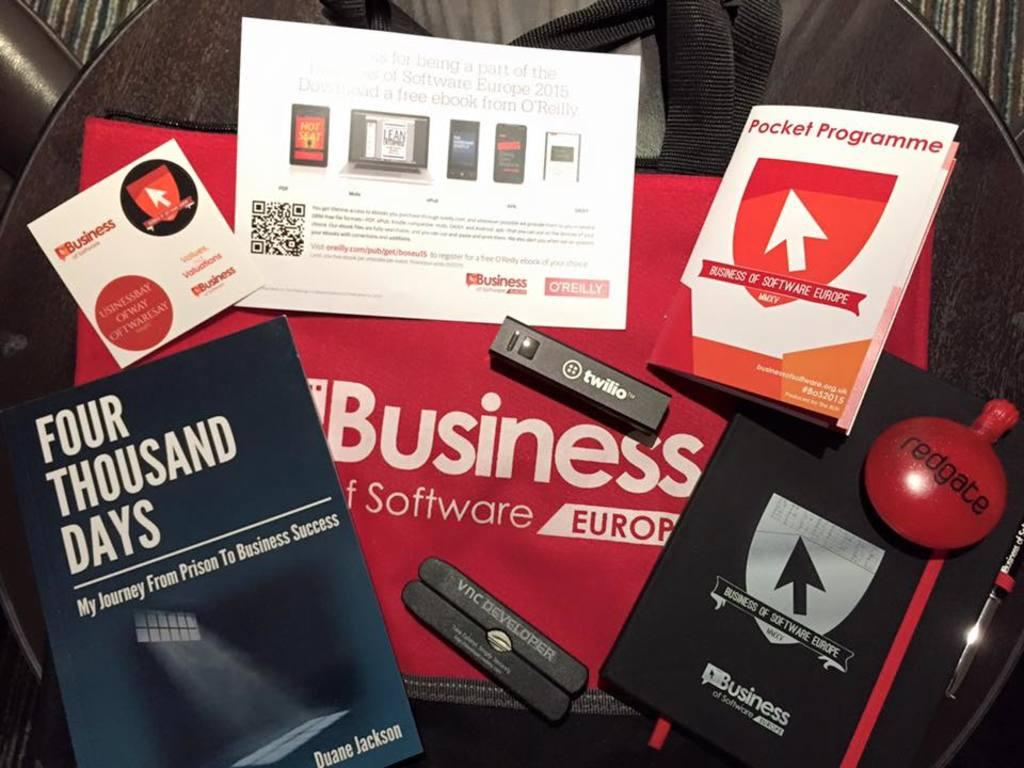<image>
Describe the image concisely. A booklet pocket programme next to other promotional products. 